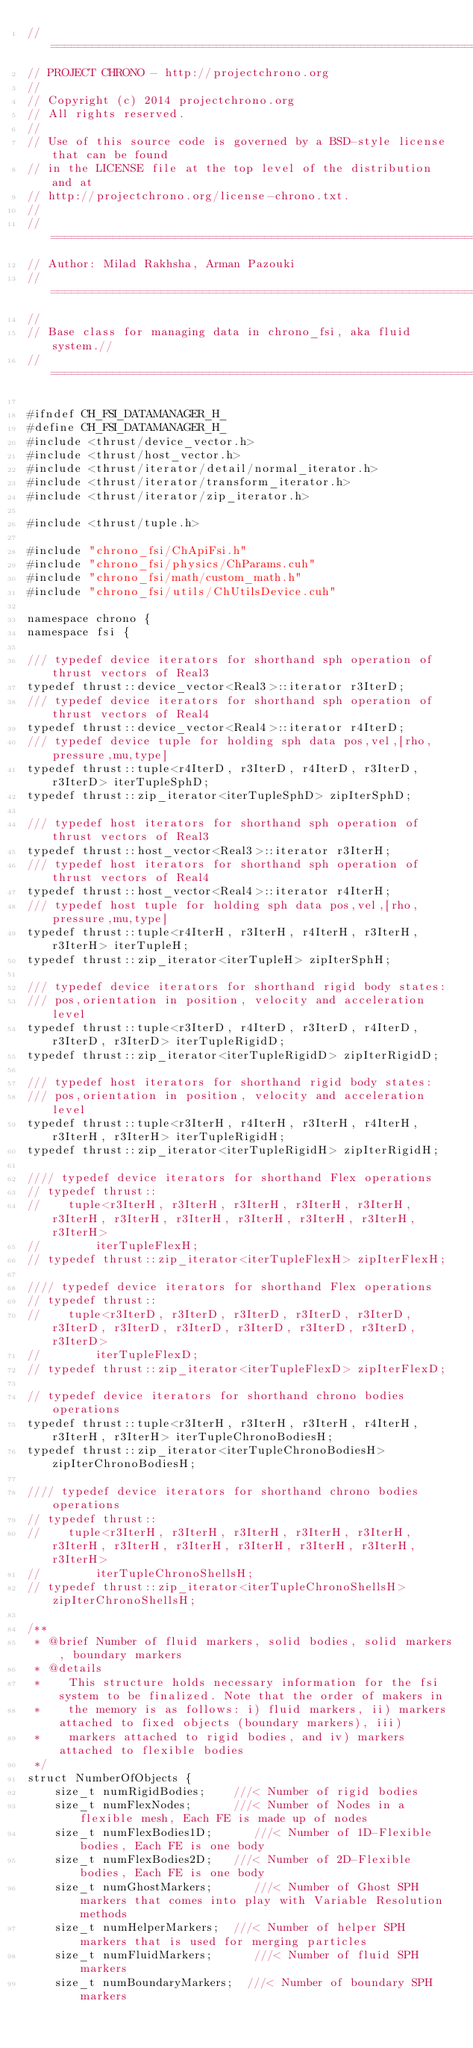<code> <loc_0><loc_0><loc_500><loc_500><_Cuda_>// =============================================================================
// PROJECT CHRONO - http://projectchrono.org
//
// Copyright (c) 2014 projectchrono.org
// All rights reserved.
//
// Use of this source code is governed by a BSD-style license that can be found
// in the LICENSE file at the top level of the distribution and at
// http://projectchrono.org/license-chrono.txt.
//
// =============================================================================
// Author: Milad Rakhsha, Arman Pazouki
// =============================================================================
//
// Base class for managing data in chrono_fsi, aka fluid system.//
// =============================================================================

#ifndef CH_FSI_DATAMANAGER_H_
#define CH_FSI_DATAMANAGER_H_
#include <thrust/device_vector.h>
#include <thrust/host_vector.h>
#include <thrust/iterator/detail/normal_iterator.h>
#include <thrust/iterator/transform_iterator.h>
#include <thrust/iterator/zip_iterator.h>

#include <thrust/tuple.h>

#include "chrono_fsi/ChApiFsi.h"
#include "chrono_fsi/physics/ChParams.cuh"
#include "chrono_fsi/math/custom_math.h"
#include "chrono_fsi/utils/ChUtilsDevice.cuh"

namespace chrono {
namespace fsi {

/// typedef device iterators for shorthand sph operation of thrust vectors of Real3
typedef thrust::device_vector<Real3>::iterator r3IterD;
/// typedef device iterators for shorthand sph operation of thrust vectors of Real4
typedef thrust::device_vector<Real4>::iterator r4IterD;
/// typedef device tuple for holding sph data pos,vel,[rho,pressure,mu,type]
typedef thrust::tuple<r4IterD, r3IterD, r4IterD, r3IterD, r3IterD> iterTupleSphD;  
typedef thrust::zip_iterator<iterTupleSphD> zipIterSphD;

/// typedef host iterators for shorthand sph operation of thrust vectors of Real3
typedef thrust::host_vector<Real3>::iterator r3IterH;
/// typedef host iterators for shorthand sph operation of thrust vectors of Real4
typedef thrust::host_vector<Real4>::iterator r4IterH;
/// typedef host tuple for holding sph data pos,vel,[rho,pressure,mu,type]
typedef thrust::tuple<r4IterH, r3IterH, r4IterH, r3IterH, r3IterH> iterTupleH;  
typedef thrust::zip_iterator<iterTupleH> zipIterSphH;

/// typedef device iterators for shorthand rigid body states:
/// pos,orientation in position, velocity and acceleration level
typedef thrust::tuple<r3IterD, r4IterD, r3IterD, r4IterD, r3IterD, r3IterD> iterTupleRigidD;
typedef thrust::zip_iterator<iterTupleRigidD> zipIterRigidD;

/// typedef host iterators for shorthand rigid body states:
/// pos,orientation in position, velocity and acceleration level
typedef thrust::tuple<r3IterH, r4IterH, r3IterH, r4IterH, r3IterH, r3IterH> iterTupleRigidH;
typedef thrust::zip_iterator<iterTupleRigidH> zipIterRigidH;

//// typedef device iterators for shorthand Flex operations
// typedef thrust::
//    tuple<r3IterH, r3IterH, r3IterH, r3IterH, r3IterH, r3IterH, r3IterH, r3IterH, r3IterH, r3IterH, r3IterH, r3IterH>
//        iterTupleFlexH;
// typedef thrust::zip_iterator<iterTupleFlexH> zipIterFlexH;

//// typedef device iterators for shorthand Flex operations
// typedef thrust::
//    tuple<r3IterD, r3IterD, r3IterD, r3IterD, r3IterD, r3IterD, r3IterD, r3IterD, r3IterD, r3IterD, r3IterD, r3IterD>
//        iterTupleFlexD;
// typedef thrust::zip_iterator<iterTupleFlexD> zipIterFlexD;

// typedef device iterators for shorthand chrono bodies operations
typedef thrust::tuple<r3IterH, r3IterH, r3IterH, r4IterH, r3IterH, r3IterH> iterTupleChronoBodiesH;
typedef thrust::zip_iterator<iterTupleChronoBodiesH> zipIterChronoBodiesH;

//// typedef device iterators for shorthand chrono bodies operations
// typedef thrust::
//    tuple<r3IterH, r3IterH, r3IterH, r3IterH, r3IterH, r3IterH, r3IterH, r3IterH, r3IterH, r3IterH, r3IterH, r3IterH>
//        iterTupleChronoShellsH;
// typedef thrust::zip_iterator<iterTupleChronoShellsH> zipIterChronoShellsH;

/**
 * @brief Number of fluid markers, solid bodies, solid markers, boundary markers
 * @details
 * 		This structure holds necessary information for the fsi system to be finalized. Note that the order of makers in
 * 		the memory is as follows: i) fluid markers, ii) markers attached to fixed objects (boundary markers), iii)
 * 		markers attached to rigid bodies, and iv) markers attached to flexible bodies
 */
struct NumberOfObjects {
    size_t numRigidBodies;    ///< Number of rigid bodies
    size_t numFlexNodes;      ///< Number of Nodes in a flexible mesh, Each FE is made up of nodes
    size_t numFlexBodies1D;      ///< Number of 1D-Flexible bodies, Each FE is one body
    size_t numFlexBodies2D;   ///< Number of 2D-Flexible bodies, Each FE is one body
    size_t numGhostMarkers;      ///< Number of Ghost SPH markers that comes into play with Variable Resolution methods
    size_t numHelperMarkers;  ///< Number of helper SPH markers that is used for merging particles
    size_t numFluidMarkers;      ///< Number of fluid SPH markers
    size_t numBoundaryMarkers;  ///< Number of boundary SPH markers</code> 